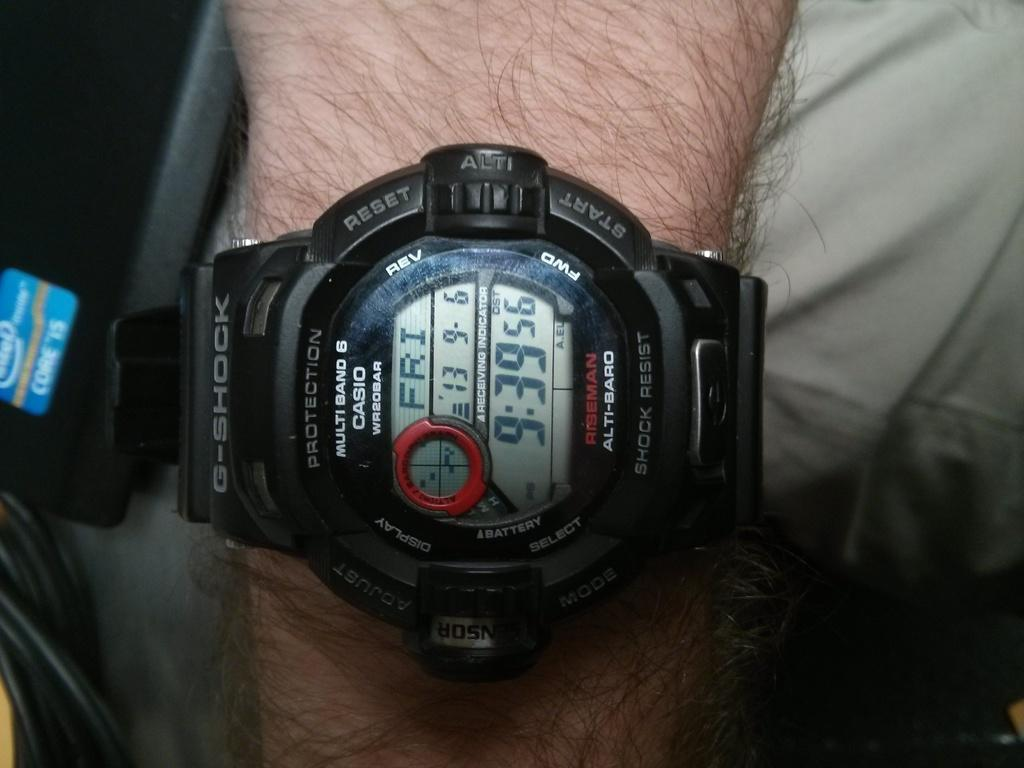<image>
Offer a succinct explanation of the picture presented. Person wearing a black watch that says CASIO on it. 